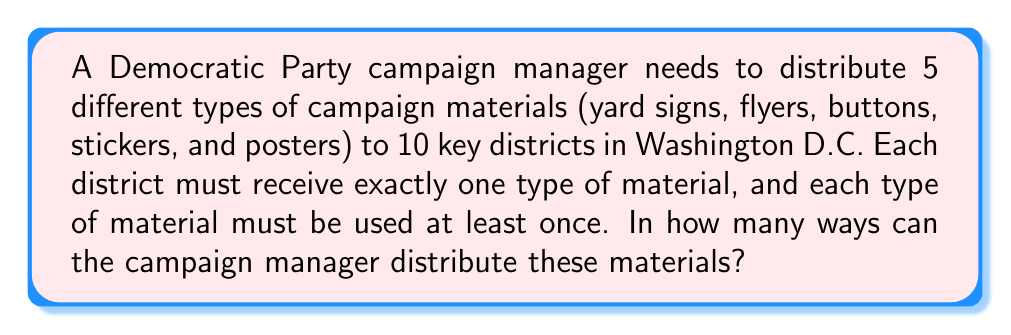Provide a solution to this math problem. Let's approach this step-by-step:

1) This is a problem of distributing distinct objects (5 types of materials) into distinct boxes (10 districts) with restrictions.

2) We can use the concept of Stirling numbers of the second kind and multiply by permutations.

3) Let $S(n,k)$ denote the Stirling number of the second kind, which represents the number of ways to partition n objects into k non-empty subsets.

4) In this case, we need to partition 10 districts into 5 groups (one for each type of material). This is represented by $S(10,5)$.

5) The Stirling number $S(10,5)$ can be calculated as:

   $$S(10,5) = \frac{1}{5!}\sum_{i=0}^5 (-1)^i \binom{5}{i}(5-i)^{10}$$

6) Calculating this gives us $S(10,5) = 42525$.

7) However, this only gives us the number of ways to partition the districts. We also need to consider the permutations of the 5 types of materials among these 5 groups.

8) The number of permutations of 5 objects is simply $5! = 120$.

9) Therefore, the total number of ways to distribute the materials is:

   $$42525 \times 120 = 5,103,000$$
Answer: $5,103,000$ 